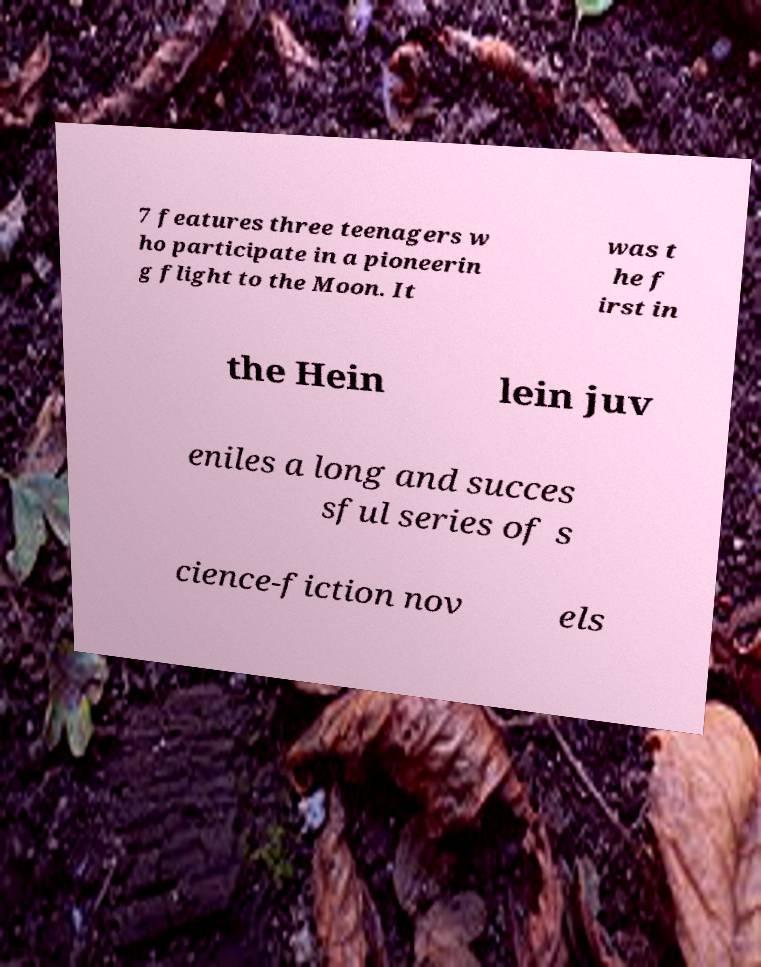Please read and relay the text visible in this image. What does it say? 7 features three teenagers w ho participate in a pioneerin g flight to the Moon. It was t he f irst in the Hein lein juv eniles a long and succes sful series of s cience-fiction nov els 